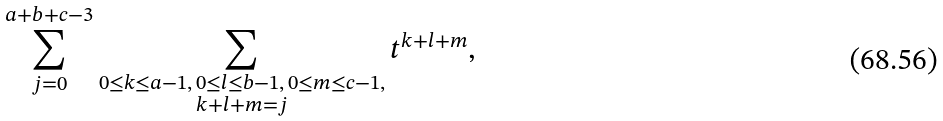Convert formula to latex. <formula><loc_0><loc_0><loc_500><loc_500>\sum _ { j = 0 } ^ { a + b + c - 3 } \sum _ { \substack { 0 \leq k \leq a - 1 , \, 0 \leq l \leq b - 1 , \, 0 \leq m \leq c - 1 , \\ k + l + m = j } } t ^ { k + l + m } ,</formula> 